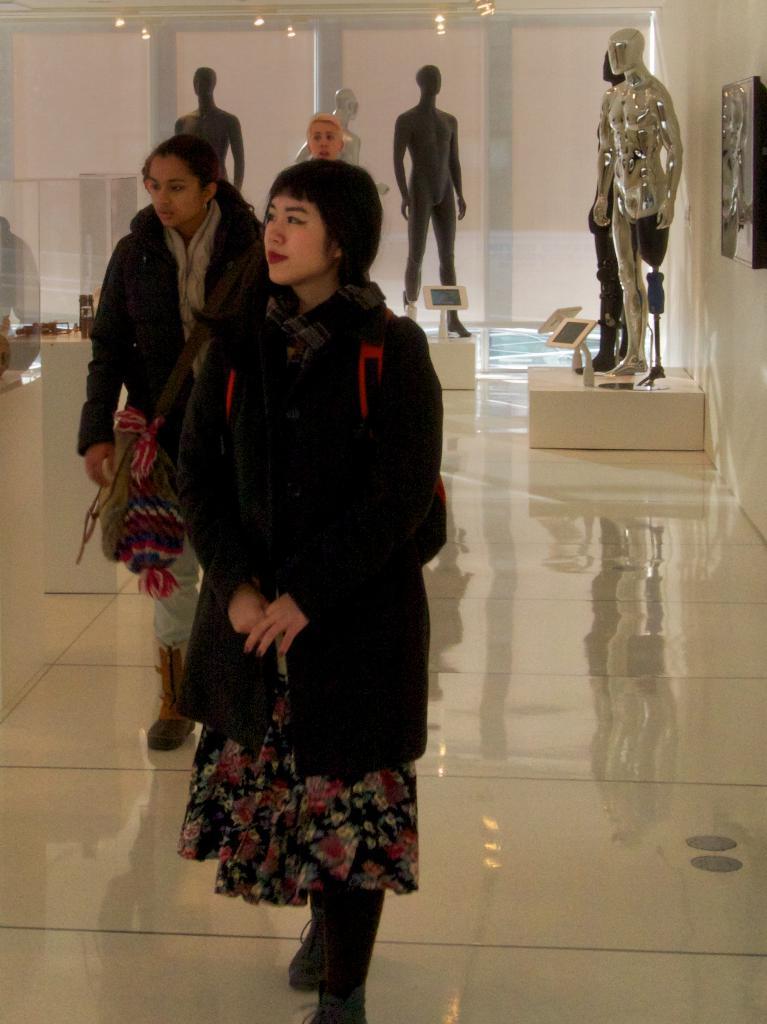Please provide a concise description of this image. In the picture I can see people standing on the floor. I can also see mannequins, an object attached to the wall, lights and some other objects. 